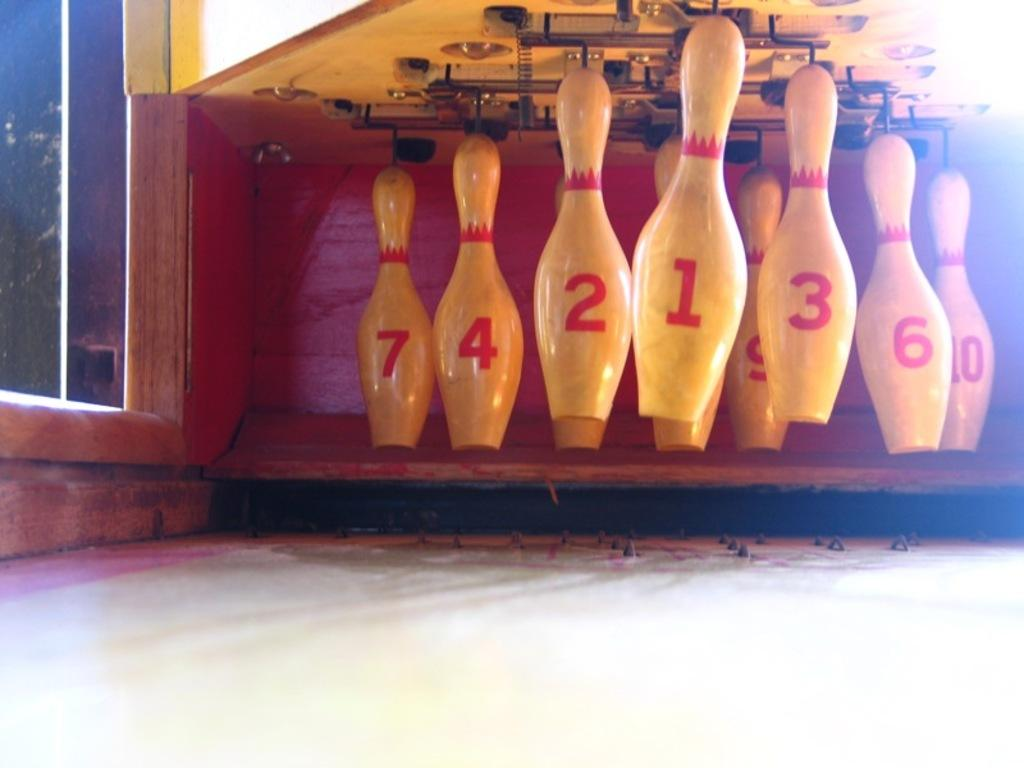What objects are present in the image? There are bowling pins in the image. Can you describe the color of the bowling pins? The bowling pins are cream-colored. What is the surface in front of the bowling pins like? There is a white surface in front of the pins. What else can be seen near the bowling pins? There is a glass to the left of the pins. How many flies are sitting on the bowling pins in the image? There are no flies present in the image; it only features bowling pins, a white surface, and a glass. 